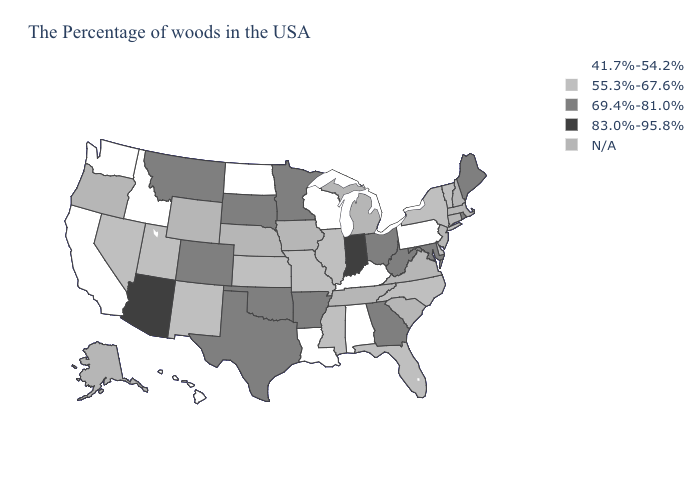Among the states that border Vermont , which have the lowest value?
Concise answer only. New York. Which states hav the highest value in the MidWest?
Short answer required. Indiana. Which states hav the highest value in the South?
Keep it brief. Maryland, West Virginia, Georgia, Arkansas, Oklahoma, Texas. What is the highest value in the USA?
Be succinct. 83.0%-95.8%. Is the legend a continuous bar?
Short answer required. No. Name the states that have a value in the range 83.0%-95.8%?
Quick response, please. Indiana, Arizona. What is the lowest value in the South?
Short answer required. 41.7%-54.2%. Name the states that have a value in the range N/A?
Quick response, please. Massachusetts, New Hampshire, Connecticut, New Jersey, Virginia, South Carolina, Michigan, Tennessee, Iowa, Nebraska, Wyoming, Oregon, Alaska. Name the states that have a value in the range 69.4%-81.0%?
Write a very short answer. Maine, Rhode Island, Maryland, West Virginia, Ohio, Georgia, Arkansas, Minnesota, Oklahoma, Texas, South Dakota, Colorado, Montana. What is the value of North Carolina?
Concise answer only. 55.3%-67.6%. Is the legend a continuous bar?
Short answer required. No. What is the value of Oregon?
Give a very brief answer. N/A. Does Florida have the highest value in the USA?
Concise answer only. No. Name the states that have a value in the range 69.4%-81.0%?
Quick response, please. Maine, Rhode Island, Maryland, West Virginia, Ohio, Georgia, Arkansas, Minnesota, Oklahoma, Texas, South Dakota, Colorado, Montana. What is the highest value in the MidWest ?
Concise answer only. 83.0%-95.8%. 